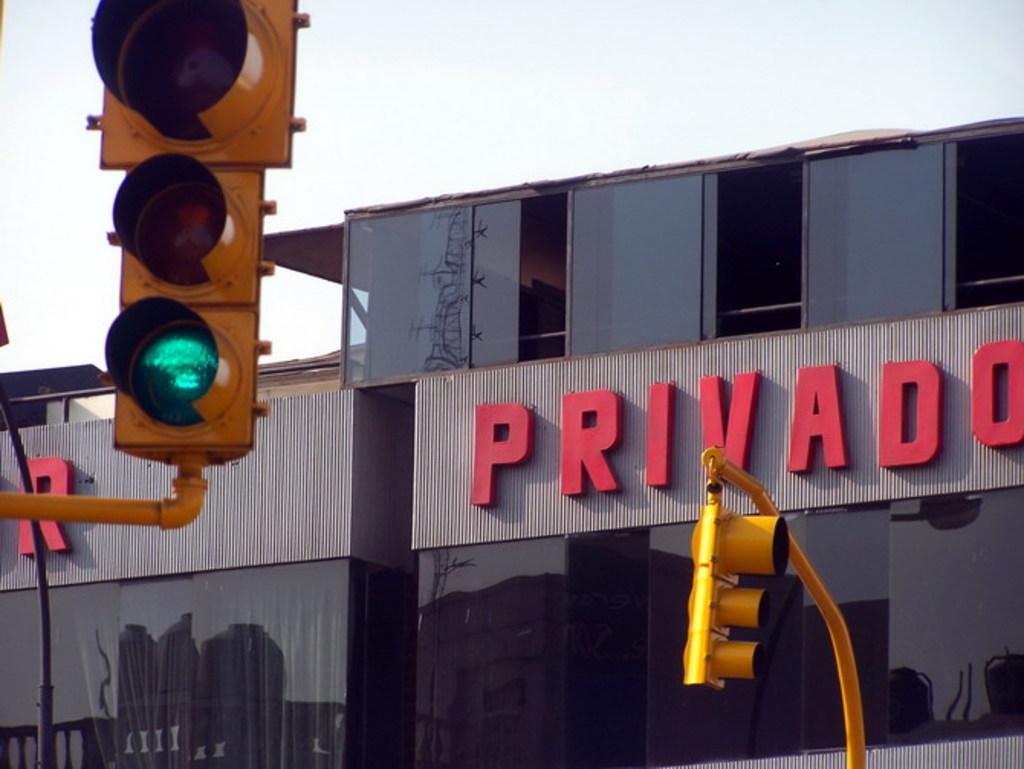What is the name of the company?
Your answer should be very brief. Privado. 